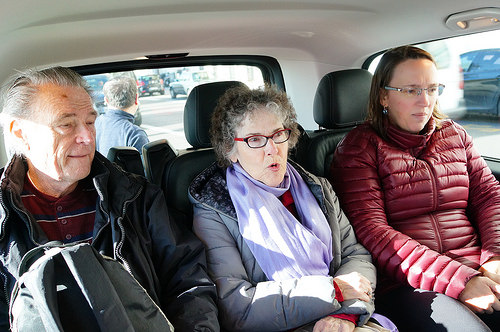<image>
Is there a lady in the chair? Yes. The lady is contained within or inside the chair, showing a containment relationship. Where is the man in relation to the car? Is it behind the car? Yes. From this viewpoint, the man is positioned behind the car, with the car partially or fully occluding the man. Is there a woman behind the window? No. The woman is not behind the window. From this viewpoint, the woman appears to be positioned elsewhere in the scene. Is there a old lady to the right of the old man? No. The old lady is not to the right of the old man. The horizontal positioning shows a different relationship. 